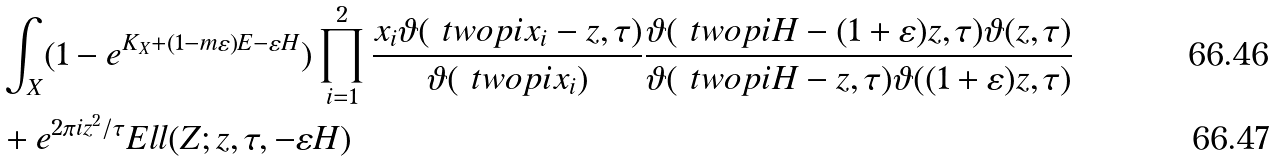<formula> <loc_0><loc_0><loc_500><loc_500>& \int _ { X } ( 1 - e ^ { K _ { X } + ( 1 - m \varepsilon ) E - \varepsilon H } ) \prod _ { i = 1 } ^ { 2 } \frac { { x _ { i } } \vartheta ( \ t w o p i { x _ { i } } - z , \tau ) } { \vartheta ( \ t w o p i { x _ { i } } ) } \frac { \vartheta ( \ t w o p i { H } - ( 1 + \varepsilon ) z , \tau ) \vartheta ( z , \tau ) } { \vartheta ( \ t w o p i { H } - z , \tau ) \vartheta ( ( 1 + \varepsilon ) z , \tau ) } \\ & + e ^ { 2 \pi i z ^ { 2 } / \tau } E l l ( Z ; z , \tau , - \varepsilon H )</formula> 